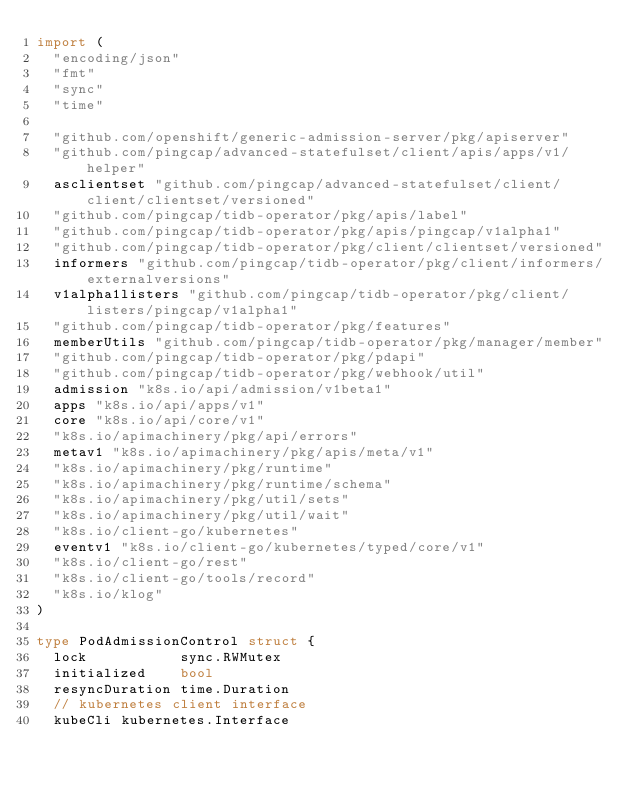<code> <loc_0><loc_0><loc_500><loc_500><_Go_>import (
	"encoding/json"
	"fmt"
	"sync"
	"time"

	"github.com/openshift/generic-admission-server/pkg/apiserver"
	"github.com/pingcap/advanced-statefulset/client/apis/apps/v1/helper"
	asclientset "github.com/pingcap/advanced-statefulset/client/client/clientset/versioned"
	"github.com/pingcap/tidb-operator/pkg/apis/label"
	"github.com/pingcap/tidb-operator/pkg/apis/pingcap/v1alpha1"
	"github.com/pingcap/tidb-operator/pkg/client/clientset/versioned"
	informers "github.com/pingcap/tidb-operator/pkg/client/informers/externalversions"
	v1alpha1listers "github.com/pingcap/tidb-operator/pkg/client/listers/pingcap/v1alpha1"
	"github.com/pingcap/tidb-operator/pkg/features"
	memberUtils "github.com/pingcap/tidb-operator/pkg/manager/member"
	"github.com/pingcap/tidb-operator/pkg/pdapi"
	"github.com/pingcap/tidb-operator/pkg/webhook/util"
	admission "k8s.io/api/admission/v1beta1"
	apps "k8s.io/api/apps/v1"
	core "k8s.io/api/core/v1"
	"k8s.io/apimachinery/pkg/api/errors"
	metav1 "k8s.io/apimachinery/pkg/apis/meta/v1"
	"k8s.io/apimachinery/pkg/runtime"
	"k8s.io/apimachinery/pkg/runtime/schema"
	"k8s.io/apimachinery/pkg/util/sets"
	"k8s.io/apimachinery/pkg/util/wait"
	"k8s.io/client-go/kubernetes"
	eventv1 "k8s.io/client-go/kubernetes/typed/core/v1"
	"k8s.io/client-go/rest"
	"k8s.io/client-go/tools/record"
	"k8s.io/klog"
)

type PodAdmissionControl struct {
	lock           sync.RWMutex
	initialized    bool
	resyncDuration time.Duration
	// kubernetes client interface
	kubeCli kubernetes.Interface</code> 